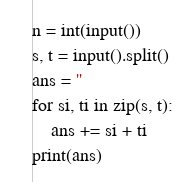<code> <loc_0><loc_0><loc_500><loc_500><_Python_>n = int(input())
s, t = input().split()
ans = ''
for si, ti in zip(s, t):
    ans += si + ti
print(ans)</code> 